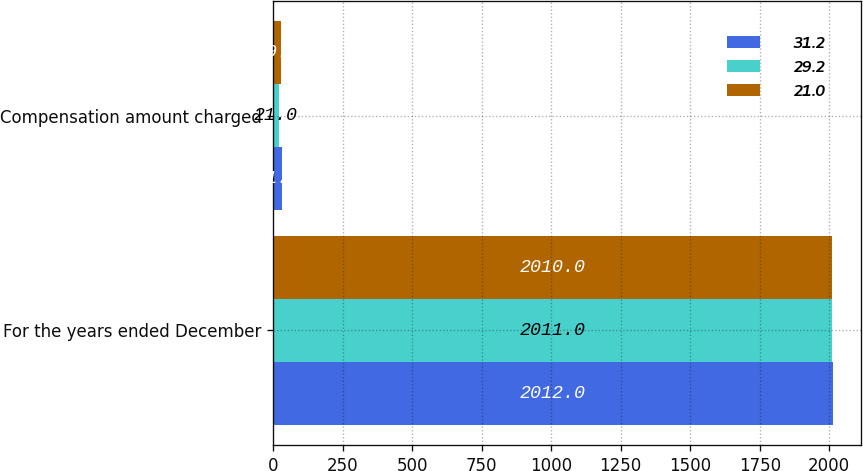<chart> <loc_0><loc_0><loc_500><loc_500><stacked_bar_chart><ecel><fcel>For the years ended December<fcel>Compensation amount charged<nl><fcel>31.2<fcel>2012<fcel>31.2<nl><fcel>29.2<fcel>2011<fcel>21<nl><fcel>21<fcel>2010<fcel>29.2<nl></chart> 